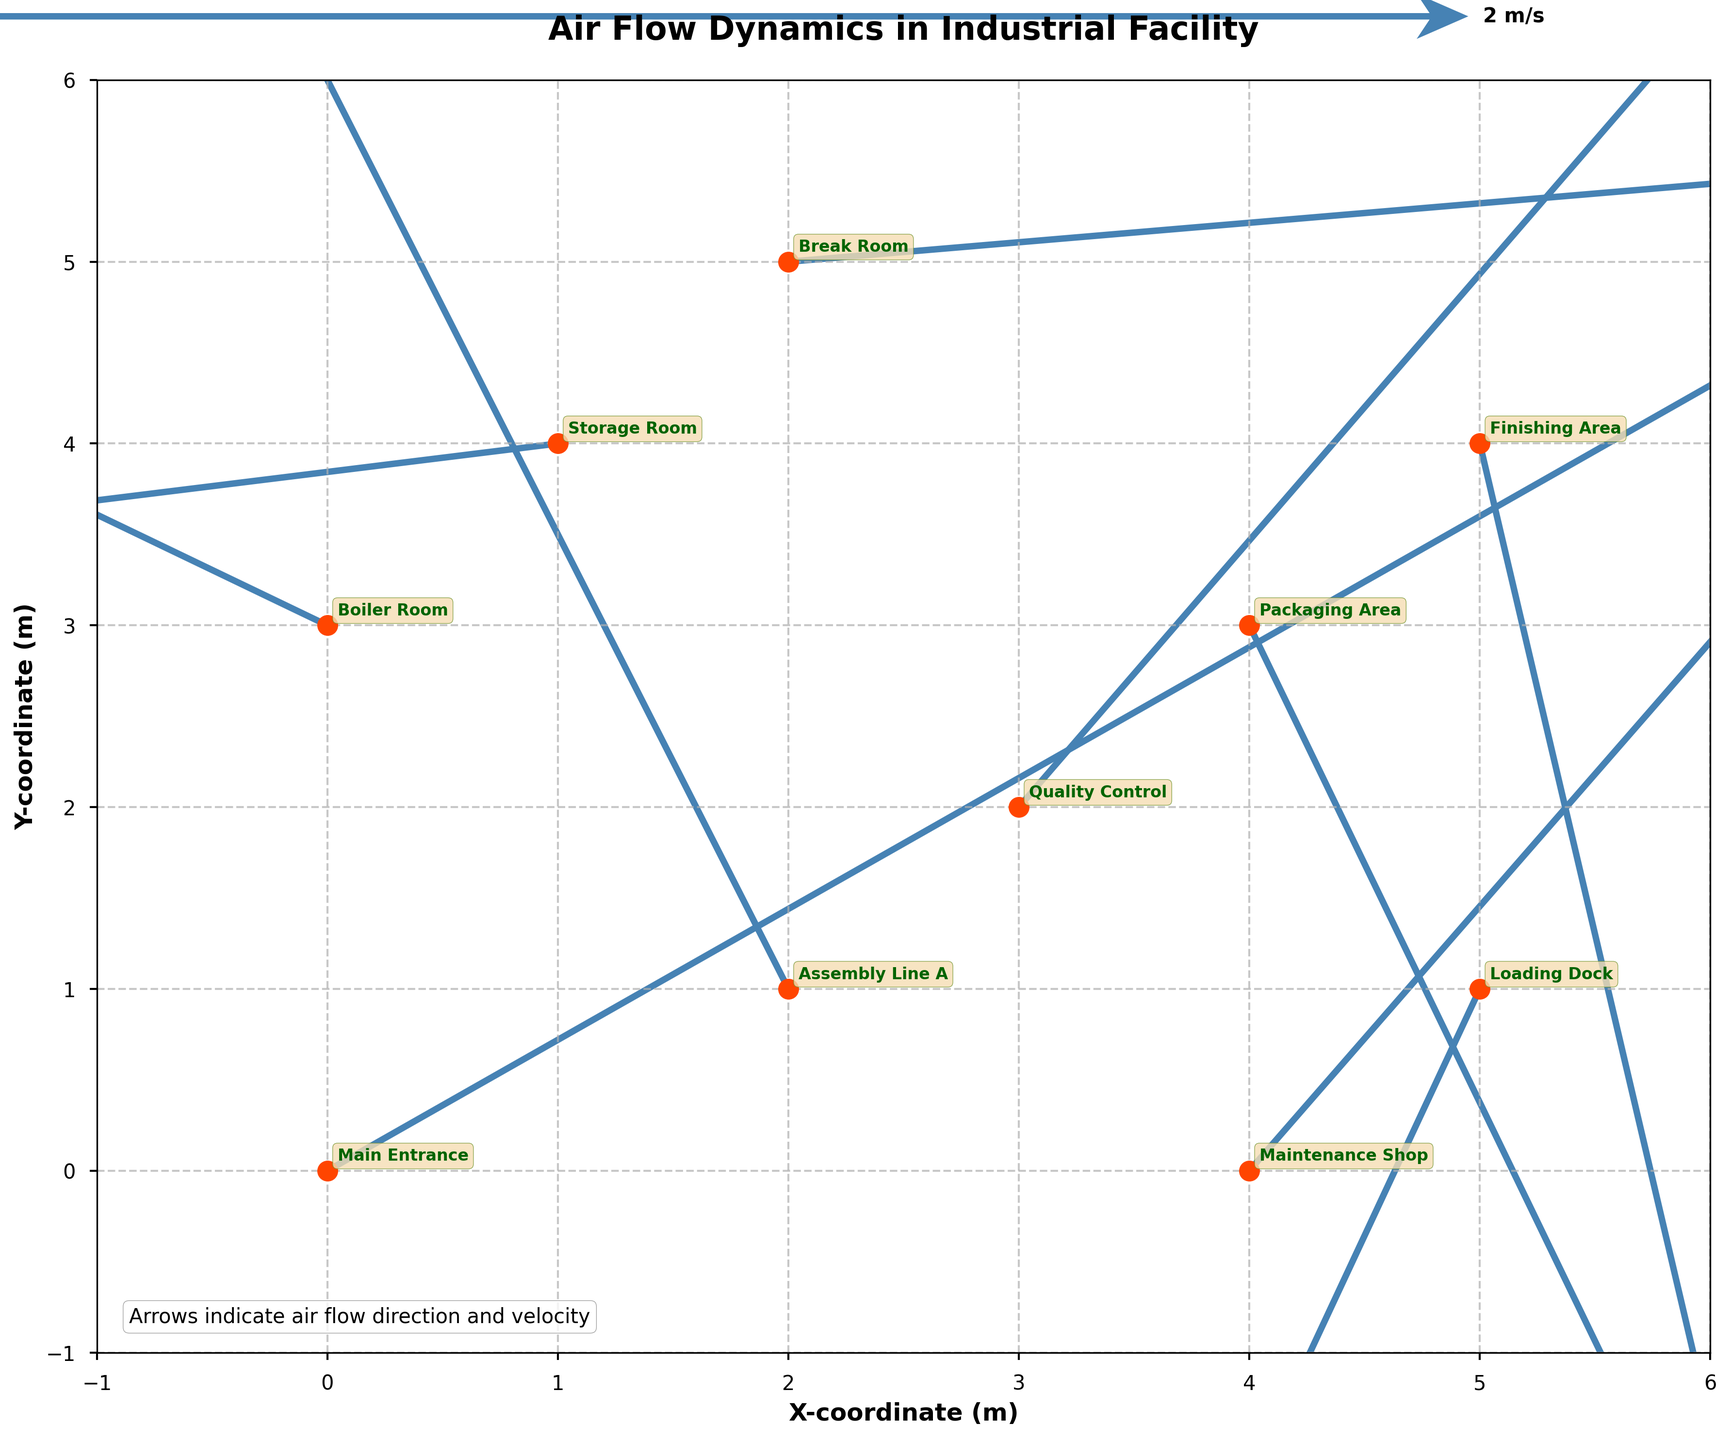how many data points are presented in the quiver plot? By counting the unique locations annotated in the figure: Main Entrance, Assembly Line A, Packaging Area, Storage Room, Quality Control, Loading Dock, Break Room, Maintenance Shop, Boiler Room, and Finishing Area, we can see there are 10 data points.
Answer: 10 Which location has the highest air velocity magnitude and what is the value? To find this, calculate the magnitude of (u, v) for each point using sqrt(u^2 + v^2). The location with the highest value is Assembly Line A with sqrt((-1.2)^2 + 3.0^2) ≈ 3.16 m/s.
Answer: Assembly Line A, 3.16 m/s What's the direction of airflow at the Boiler Room? Observing the arrow at the Boiler Room location (x=0, y=3), the arrow pointing in the direction from the tail to the head indicates airflow with direction vectors u=-2.3 and v=1.4, meaning the airflow moves towards the left and slightly upwards.
Answer: Left and Upwards How many locations exhibit a downward airflow component (negative v values)? By examining each location, we see Packaging Area (v=-2.1), Storage Room (v=-0.5), Loading Dock (v=-1.9), and Finishing Area (v=-2.7) have negative v values. Thus, there are 4 such locations.
Answer: 4 At what location is the air flowing directly leftward? Airflow directly left would have u negative and v close to zero. Checking these conditions, the Storage Room (u=-3.2, v=-0.5) is the closest match.
Answer: Storage Room Compare the air velocity at Break Room and Quality Control. Which location has a higher airflow speed? Calculate the magnitudes: Break Room has sqrt(2.8^2 + 0.3^2) ≈ 2.81 m/s and Quality Control has sqrt(1.5^2 + 2.2^2) ≈ 2.68 m/s. Break Room has a higher airflow speed.
Answer: Break Room What's the average x-coordinate of all data points in the plot? Sum the x-coordinates: 0 + 2 + 4 + 1 + 3 + 5 + 2 + 4 + 0 + 5 = 26. Since there are 10 points, the average x-coordinate is 26 / 10 = 2.6.
Answer: 2.6 